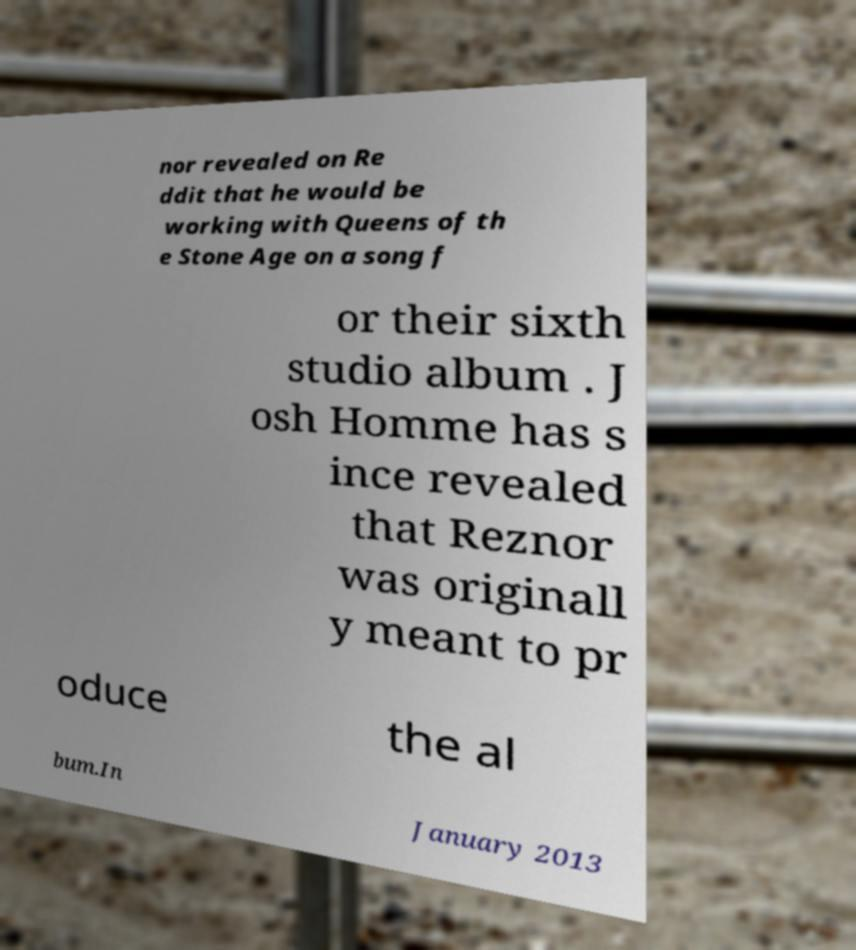Could you assist in decoding the text presented in this image and type it out clearly? nor revealed on Re ddit that he would be working with Queens of th e Stone Age on a song f or their sixth studio album . J osh Homme has s ince revealed that Reznor was originall y meant to pr oduce the al bum.In January 2013 